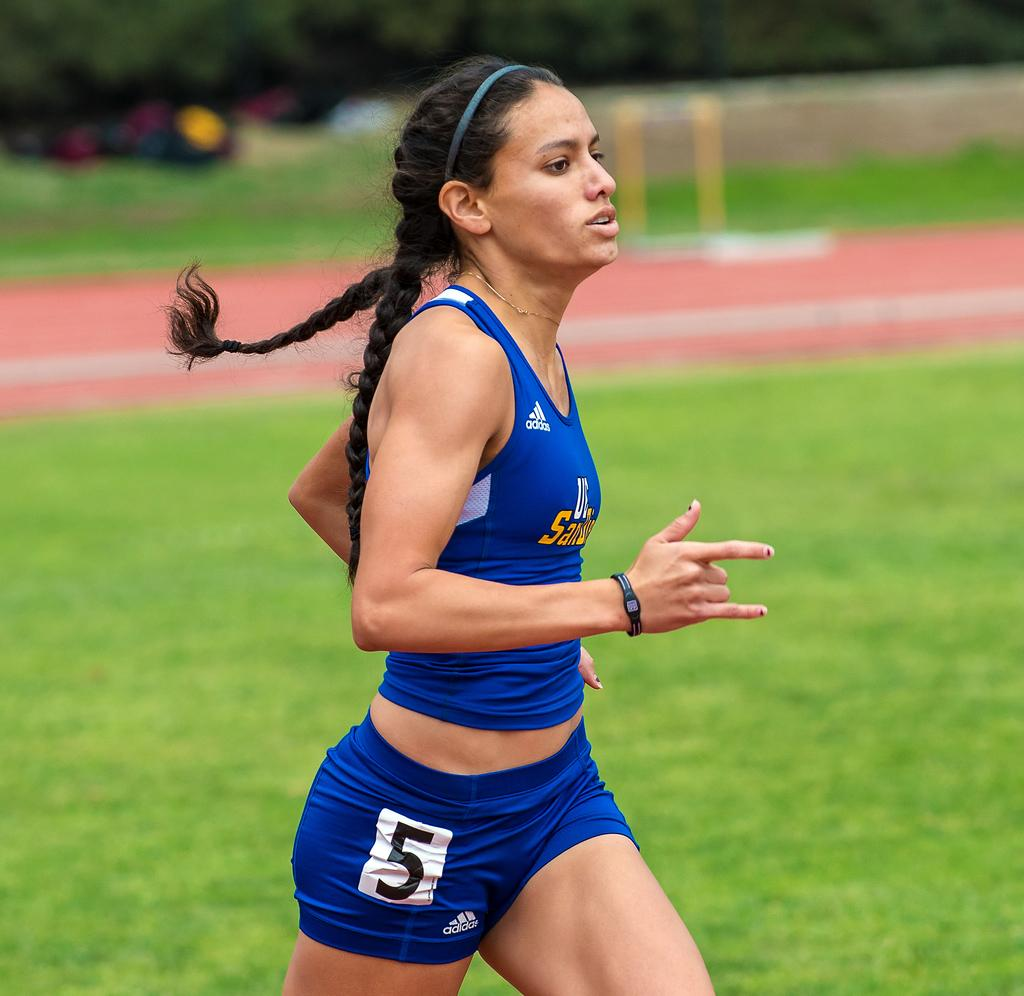<image>
Relay a brief, clear account of the picture shown. A female runner wearing blue uniform with 5 written on the hip rushes by. 